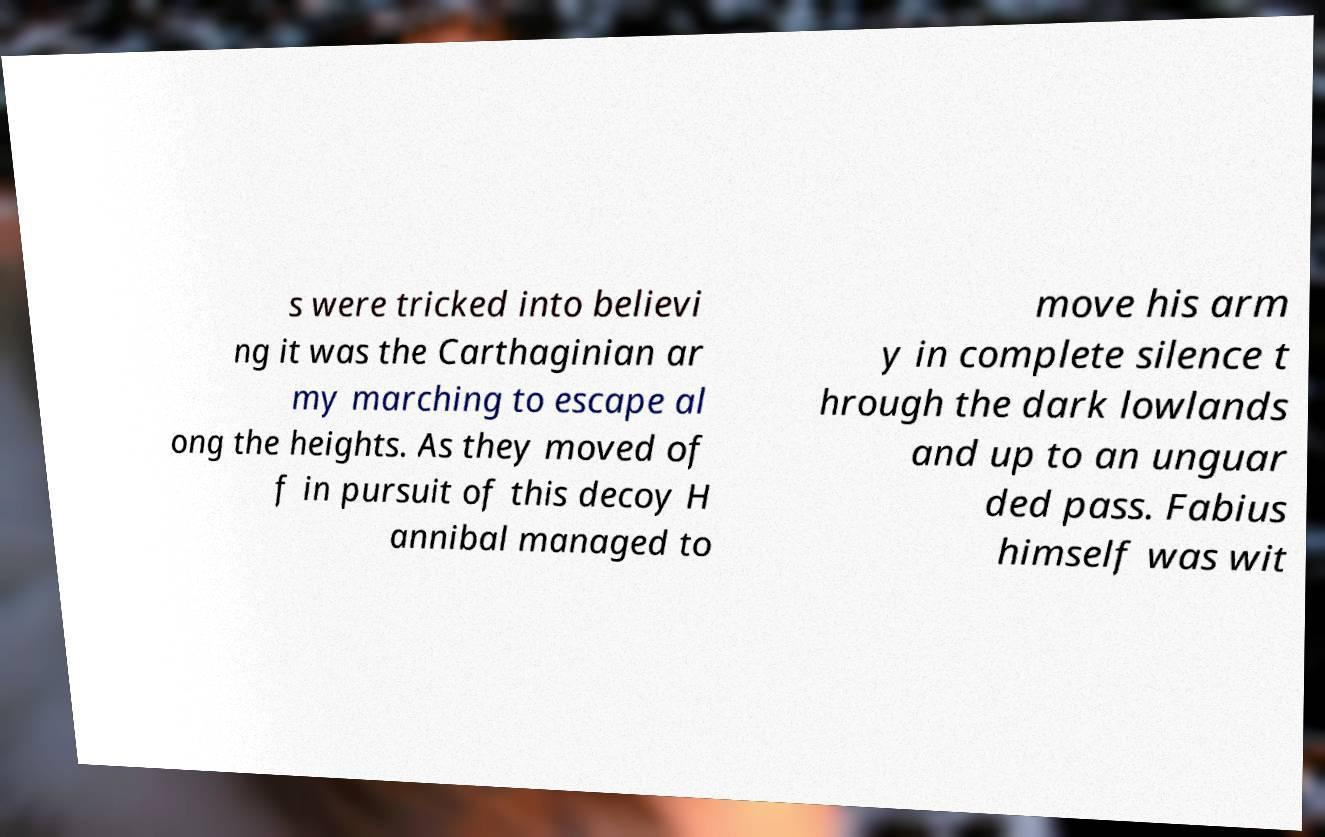Please identify and transcribe the text found in this image. s were tricked into believi ng it was the Carthaginian ar my marching to escape al ong the heights. As they moved of f in pursuit of this decoy H annibal managed to move his arm y in complete silence t hrough the dark lowlands and up to an unguar ded pass. Fabius himself was wit 